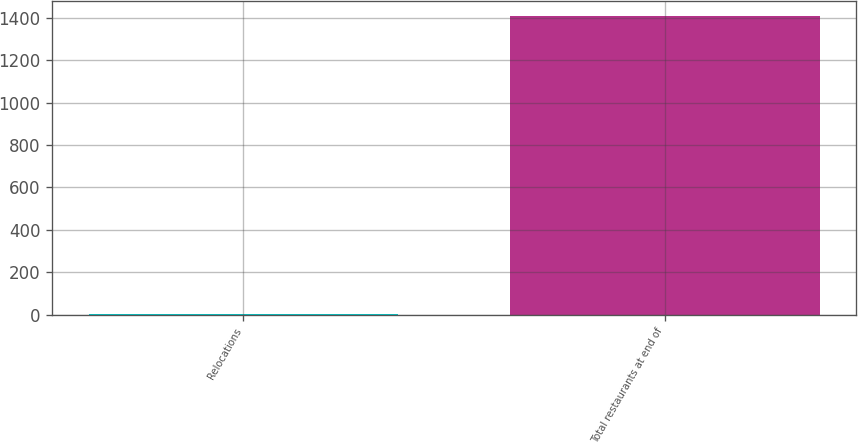Convert chart. <chart><loc_0><loc_0><loc_500><loc_500><bar_chart><fcel>Relocations<fcel>Total restaurants at end of<nl><fcel>3<fcel>1410<nl></chart> 